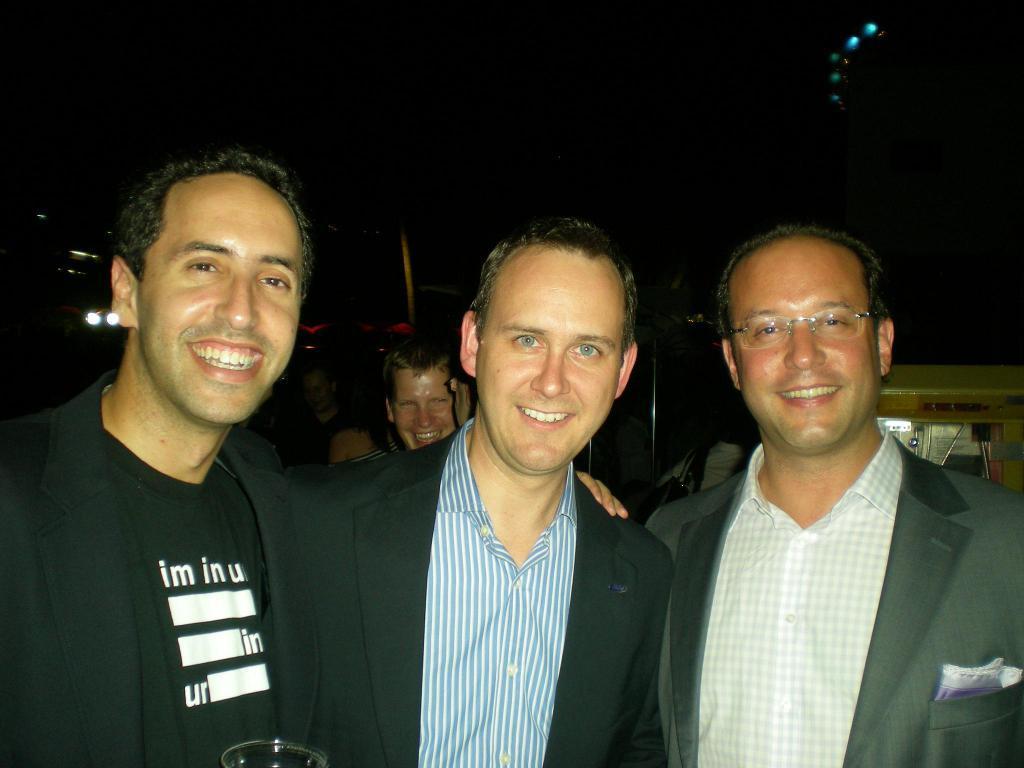How would you summarize this image in a sentence or two? In this picture there are three men who are smiling. In the back we can see persons were standing on the floor. A the top there is a darkness. On the right background we can see the vehicle. 